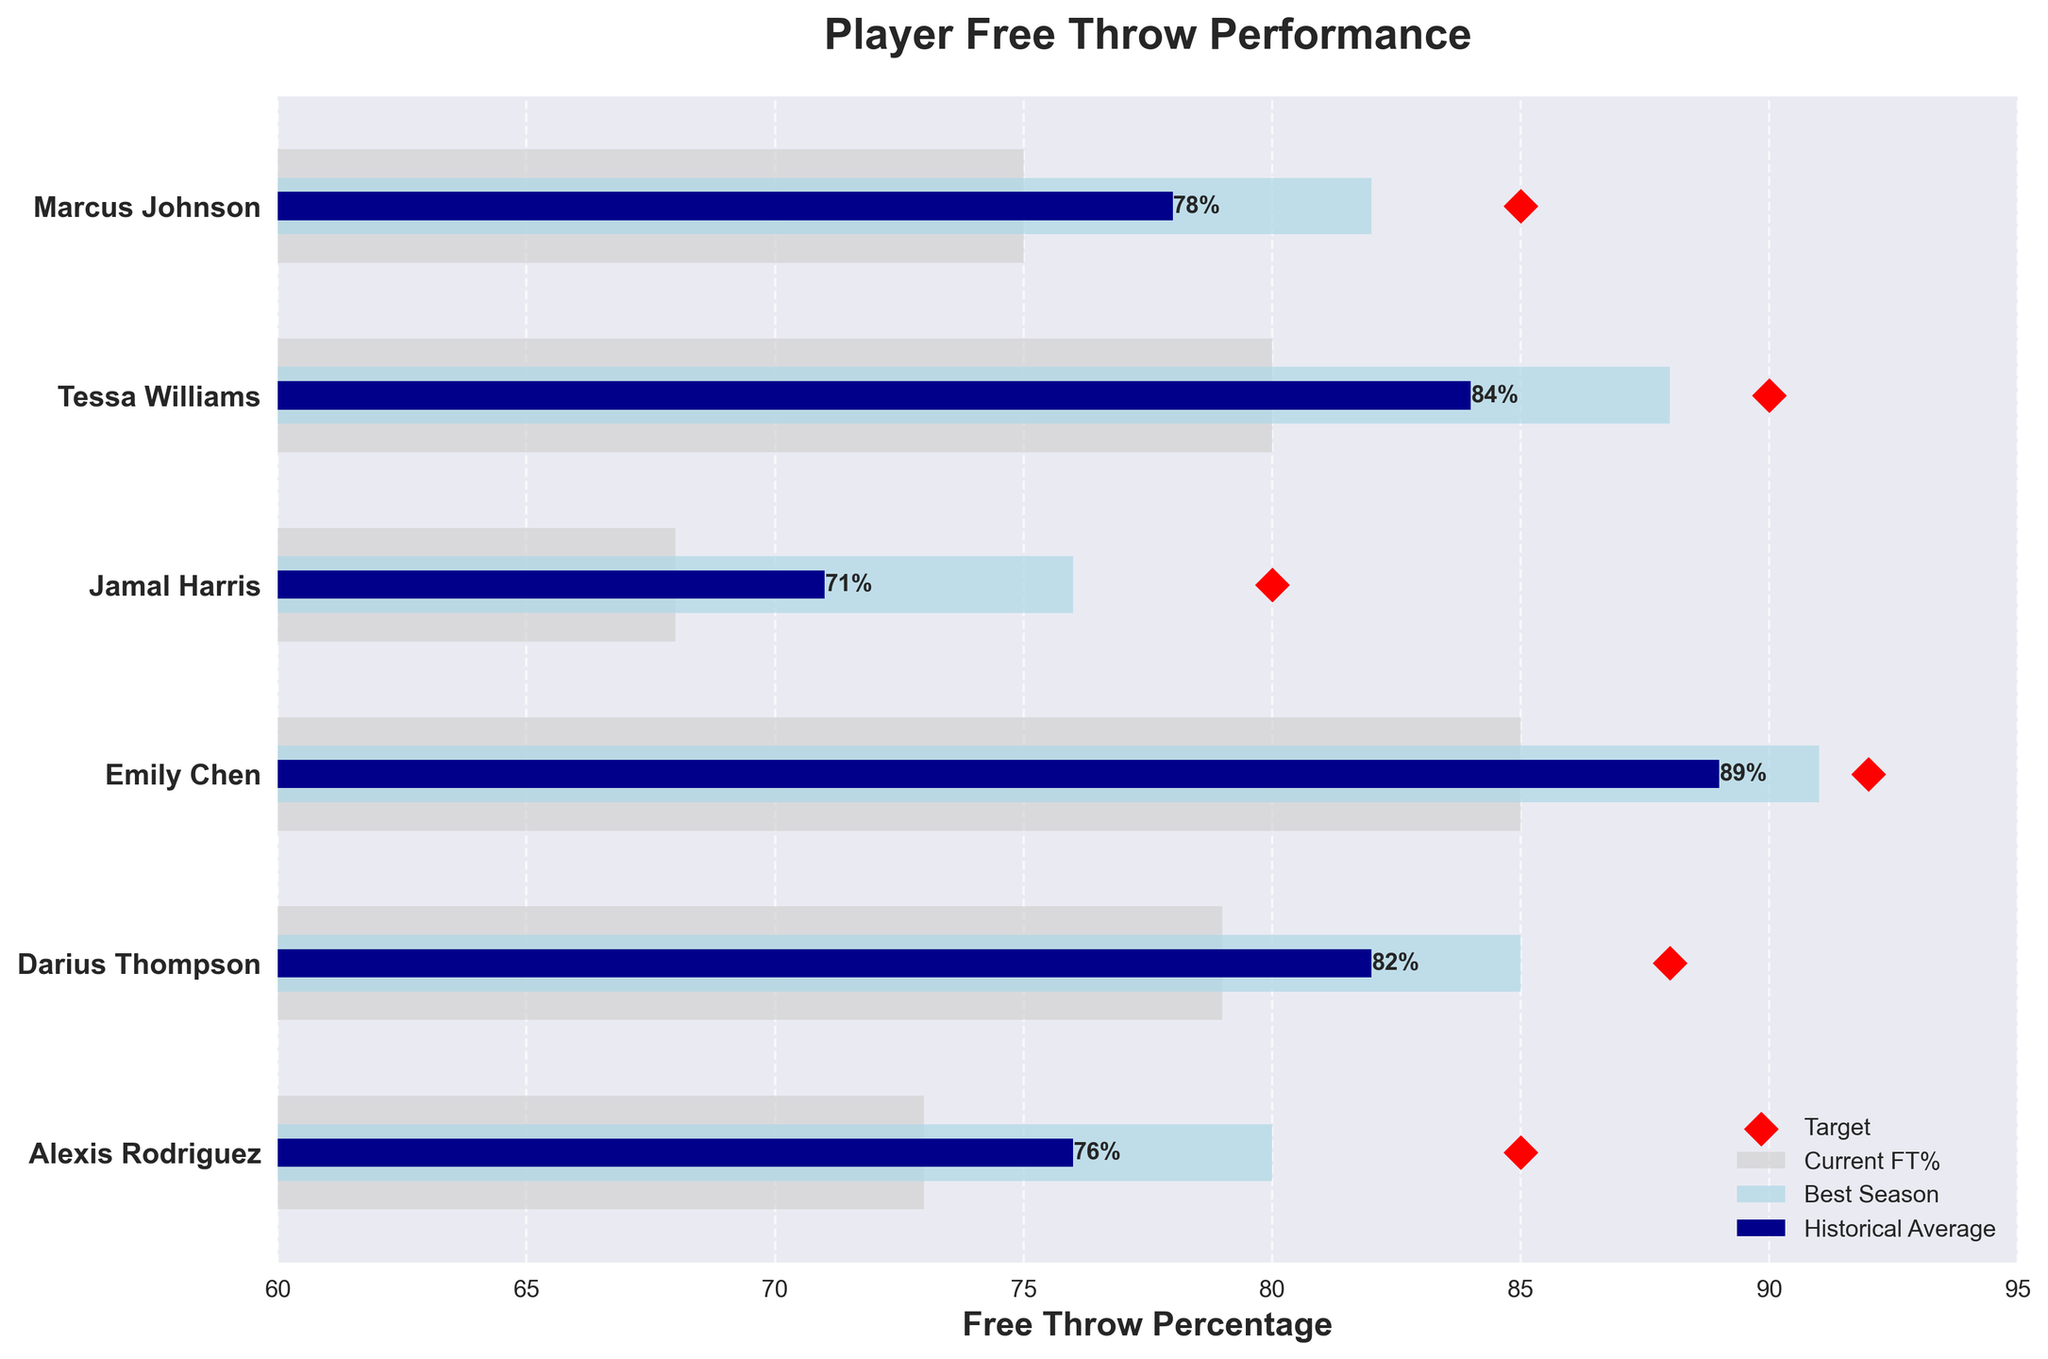Who has the highest current free throw percentage? By looking at the figure, observe the bar representing the current free throw percentage. The highest bar represents the highest free throw percentage.
Answer: Emily Chen What is the target free throw percentage for Darius Thompson? Locate Darius Thompson on the y-axis. The red diamond shape at the end of his row shows the target percentage.
Answer: 88 Which player has the greatest difference between their current free throw percentage and their target? Calculate the difference between the current and target percentages for each player. The player with the largest numerical difference has the greatest discrepancy.
Answer: Jamal Harris How does Marcus Johnson's current free throw percentage compare to the historical team average? Compare Marcus Johnson's current free throw percentage bar to the grey bar indicating the historical average.
Answer: Higher What percentage has Tessa Williams achieved compared to her best season? Look at Tessa Williams's current free throw percentage and compare it to the light blue bar indicating her best season.
Answer: 84 compared to 88 Which player is closest to their target free throw percentage? Find the player whose current free throw percentage bar is nearest to their target red diamond marker.
Answer: Emily Chen How many players have a current free throw percentage above the historical average? For each player, check if their current free throw percentage bar exceeds the grey historical average bar. Count such instances.
Answer: 4 What is the average historical free throw percentage for all players? Sum all historical average percentages and divide by the number of players: (75+80+68+85+79+73)/6.
Answer: 76.67 Who improved the most compared to the historical team average? Calculate the difference between each player's current free throw percentage and the historical average. The highest positive difference indicates the most improvement.
Answer: Emily Chen 